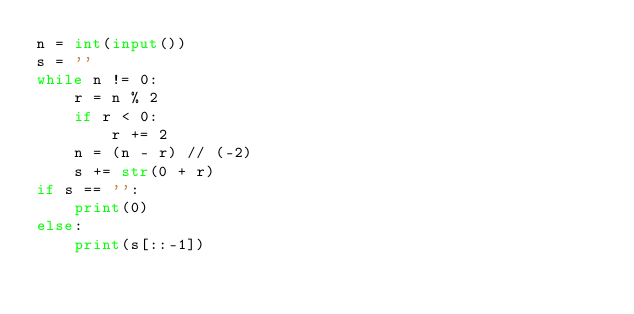Convert code to text. <code><loc_0><loc_0><loc_500><loc_500><_Python_>n = int(input())
s = ''
while n != 0:
    r = n % 2
    if r < 0:
        r += 2
    n = (n - r) // (-2)
    s += str(0 + r)
if s == '':
    print(0)
else:
    print(s[::-1])
</code> 